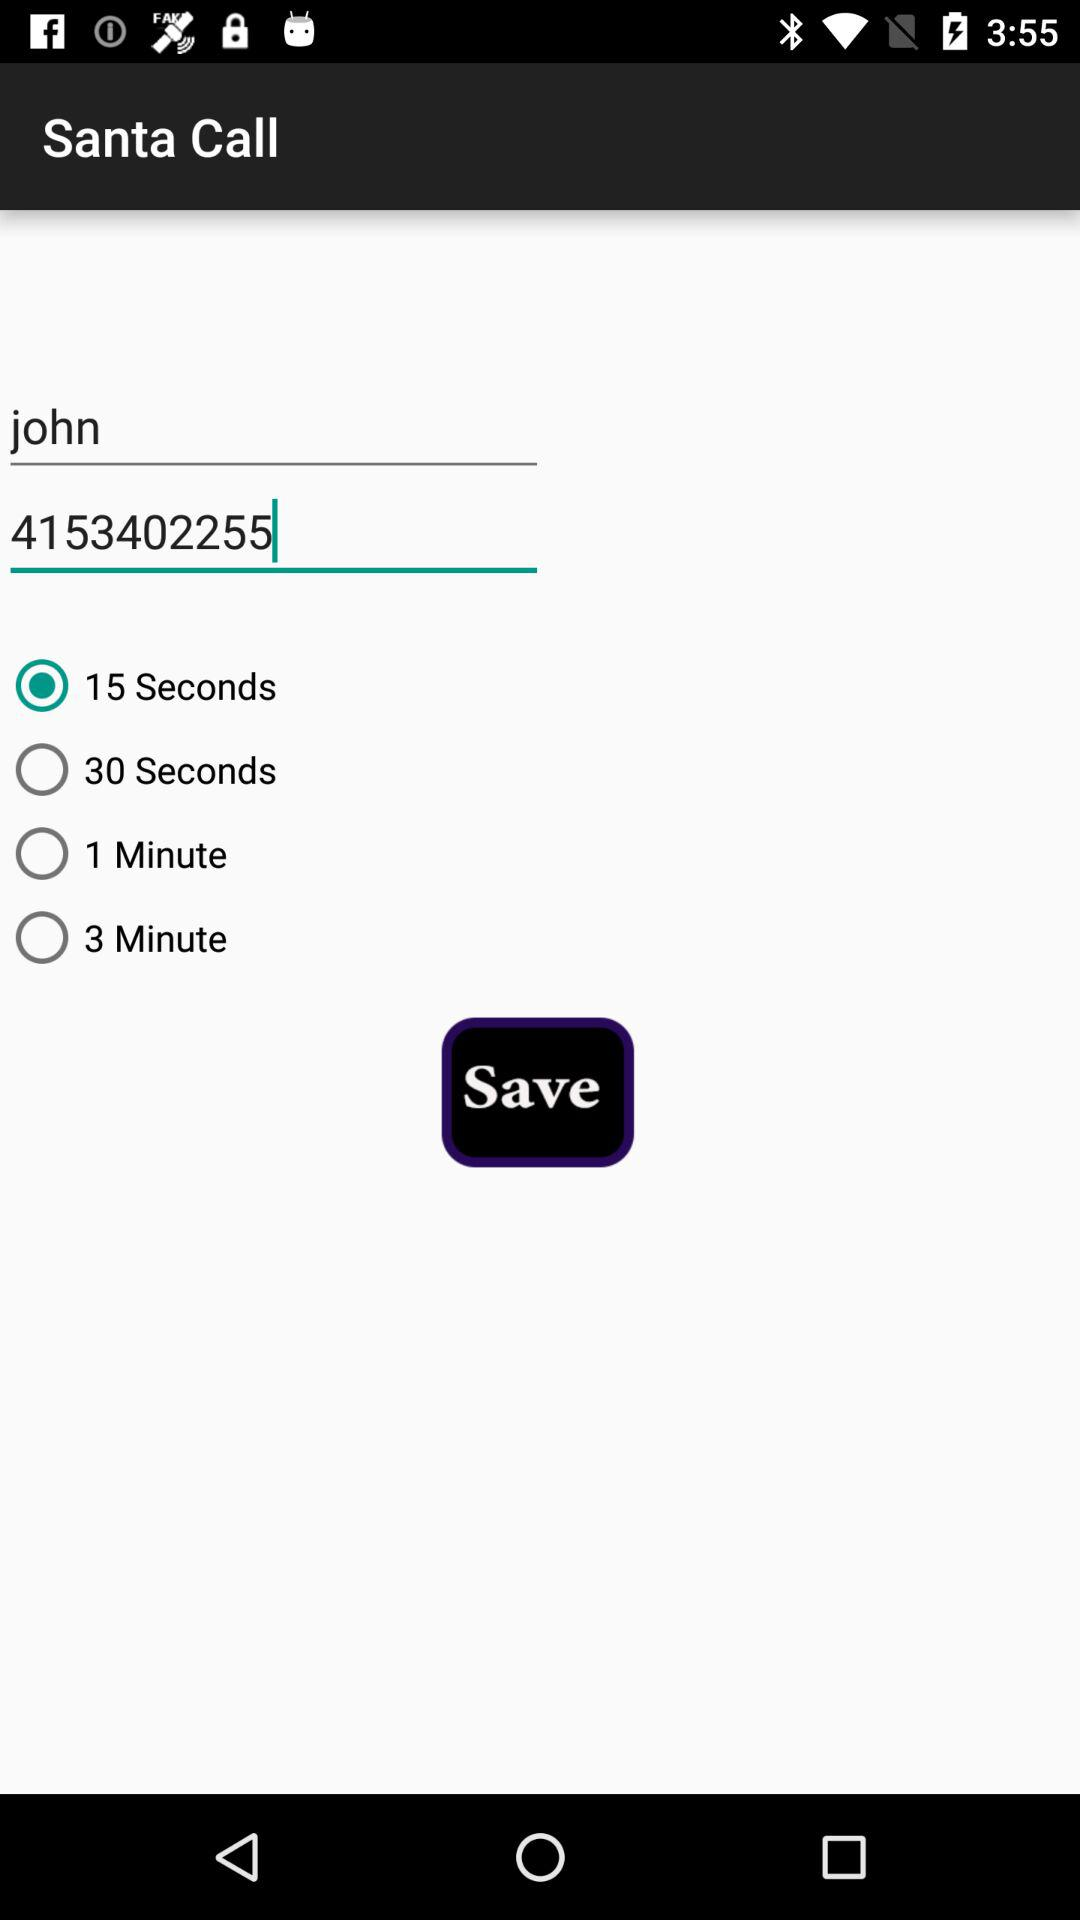How many seconds is the longest wait time?
Answer the question using a single word or phrase. 3 minutes 